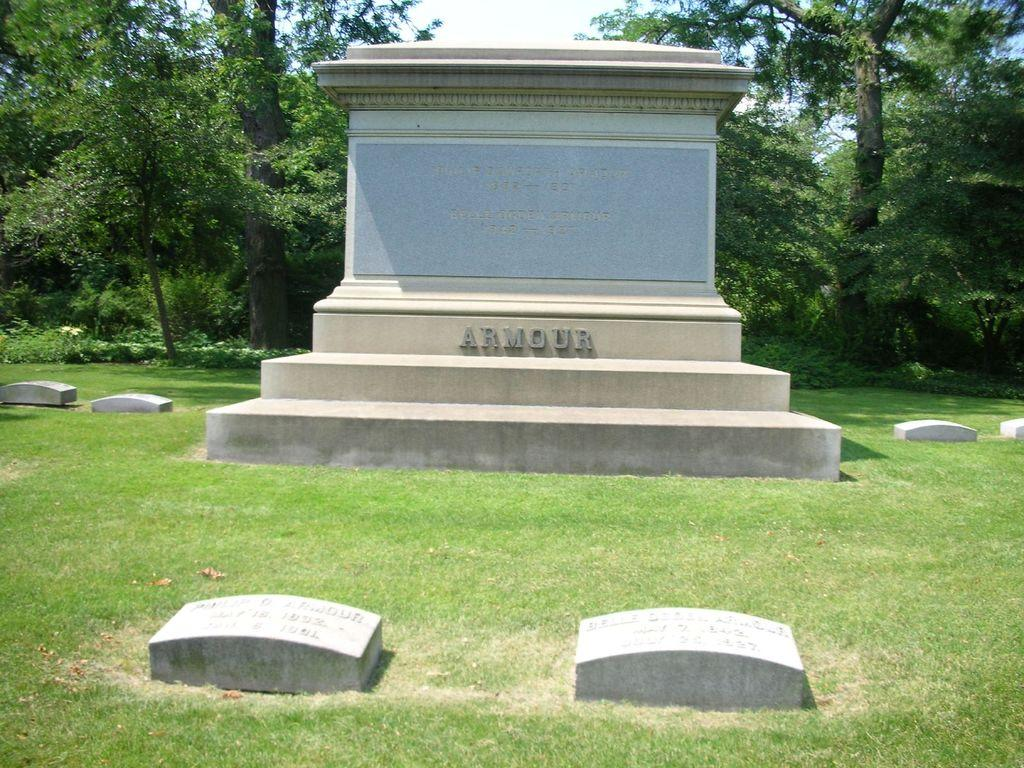What is the main subject of the image? There is a memorial in the image. What type of ground cover can be seen in the image? There is grass in the image. What other natural elements are present in the image? The bark of trees and plants are visible in the image. How many types of vegetation can be seen in the image? There are trees and plants in the image. What is the condition of the sky in the image? The sky is visible in the image, and it looks cloudy. What type of art can be seen on the memorial in the image? There is no specific art mentioned or visible on the memorial in the image. What letters are engraved on the stones in the image? There are no letters visible on the stones in the image. 